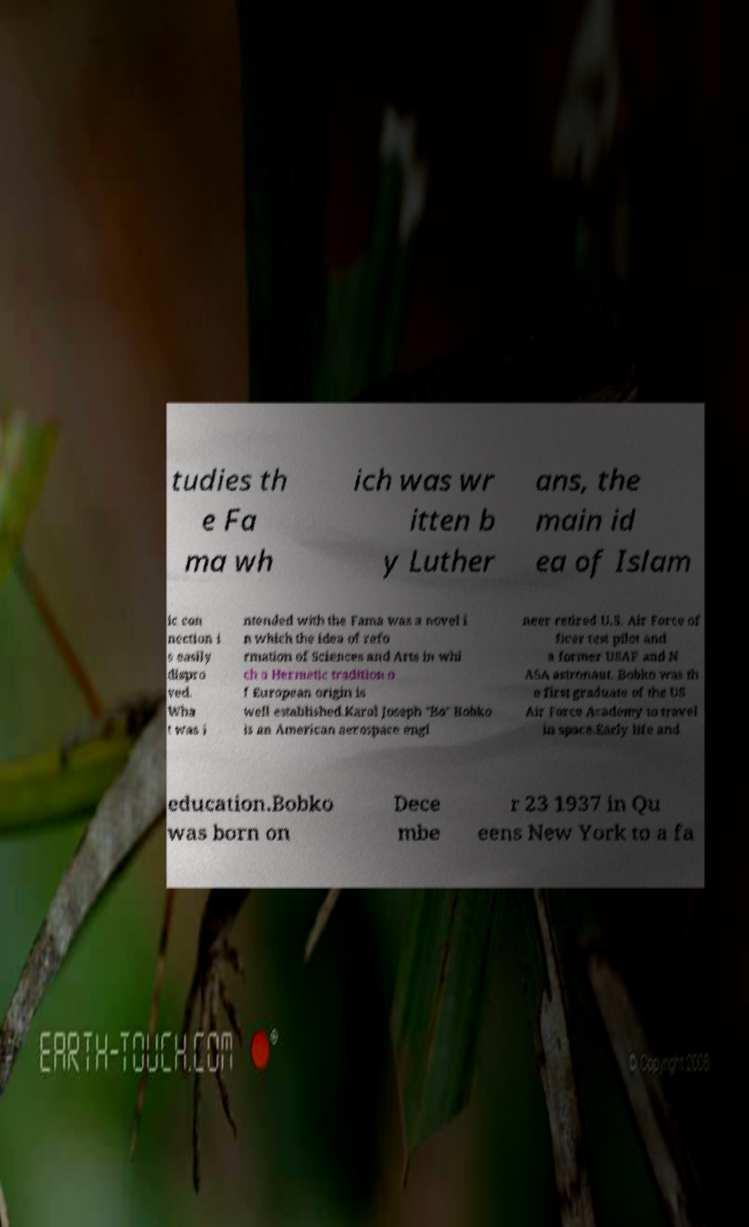Could you assist in decoding the text presented in this image and type it out clearly? tudies th e Fa ma wh ich was wr itten b y Luther ans, the main id ea of Islam ic con nection i s easily dispro ved. Wha t was i ntended with the Fama was a novel i n which the idea of refo rmation of Sciences and Arts in whi ch a Hermetic tradition o f European origin is well established.Karol Joseph "Bo" Bobko is an American aerospace engi neer retired U.S. Air Force of ficer test pilot and a former USAF and N ASA astronaut. Bobko was th e first graduate of the US Air Force Academy to travel in space.Early life and education.Bobko was born on Dece mbe r 23 1937 in Qu eens New York to a fa 